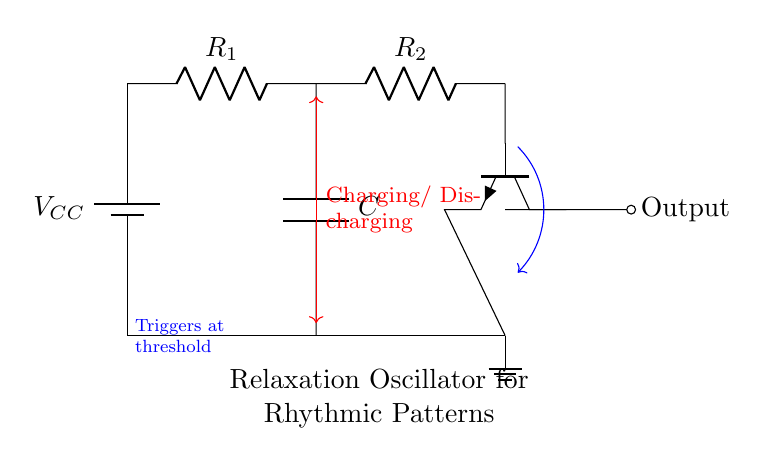What is the main function of the circuit? The circuit functions as a relaxation oscillator, which generates rhythmic patterns suitable for electronic music composition. This is indicated by the label "Relaxation Oscillator for Rhythmic Patterns" within the circuit diagram.
Answer: Relaxation oscillator What is the purpose of the capacitor in this circuit? The capacitor is used to store and release electrical energy, which is crucial for the charging and discharging process, leading to the oscillation. This is supported by the annotation showing "Charging/ Discharging."
Answer: Store and release How many resistors are present in the circuit? There are two resistors depicted in the diagram, labeled R1 and R2. This is observable from the circuit's visual representation where both resistors are shown connected in series.
Answer: Two What triggers the output in this oscillator circuit? The output is triggered at a specific voltage threshold, as indicated by the annotation stating “Triggers at threshold.” This means when the voltage across a certain point reaches a certain level, the output changes state.
Answer: Voltage threshold What component type is primarily responsible for switching in the circuit? The transistor shown in the circuit is the primary component responsible for switching. Its function is to act as a switch that allows the current to flow in response to the input voltage levels. This is identifiable by the presence of the npn transistor symbol in the diagram.
Answer: Transistor What type of connection do the components R1 and R2 have? The resistors R1 and R2 are connected in series, which means the current must flow through R1 before it can flow through R2. This can be inferred as they are positioned along the same path in the circuit layout.
Answer: Series 